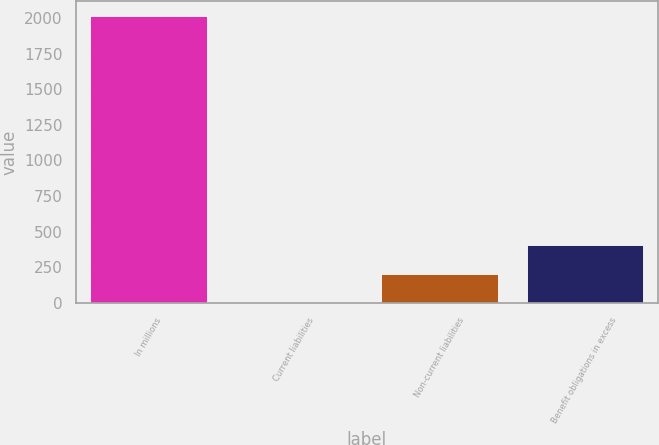Convert chart. <chart><loc_0><loc_0><loc_500><loc_500><bar_chart><fcel>In millions<fcel>Current liabilities<fcel>Non-current liabilities<fcel>Benefit obligations in excess<nl><fcel>2016<fcel>3.2<fcel>204.48<fcel>405.76<nl></chart> 